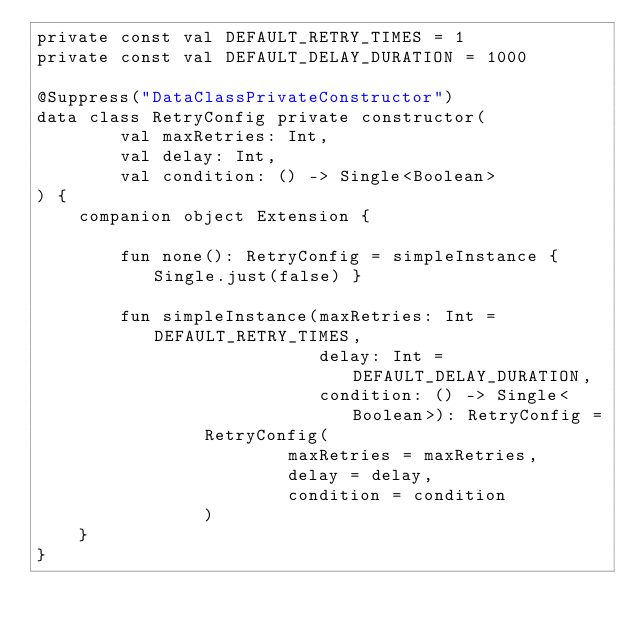<code> <loc_0><loc_0><loc_500><loc_500><_Kotlin_>private const val DEFAULT_RETRY_TIMES = 1
private const val DEFAULT_DELAY_DURATION = 1000

@Suppress("DataClassPrivateConstructor")
data class RetryConfig private constructor(
        val maxRetries: Int,
        val delay: Int,
        val condition: () -> Single<Boolean>
) {
    companion object Extension {

        fun none(): RetryConfig = simpleInstance { Single.just(false) }

        fun simpleInstance(maxRetries: Int = DEFAULT_RETRY_TIMES,
                           delay: Int = DEFAULT_DELAY_DURATION,
                           condition: () -> Single<Boolean>): RetryConfig =
                RetryConfig(
                        maxRetries = maxRetries,
                        delay = delay,
                        condition = condition
                )
    }
}</code> 